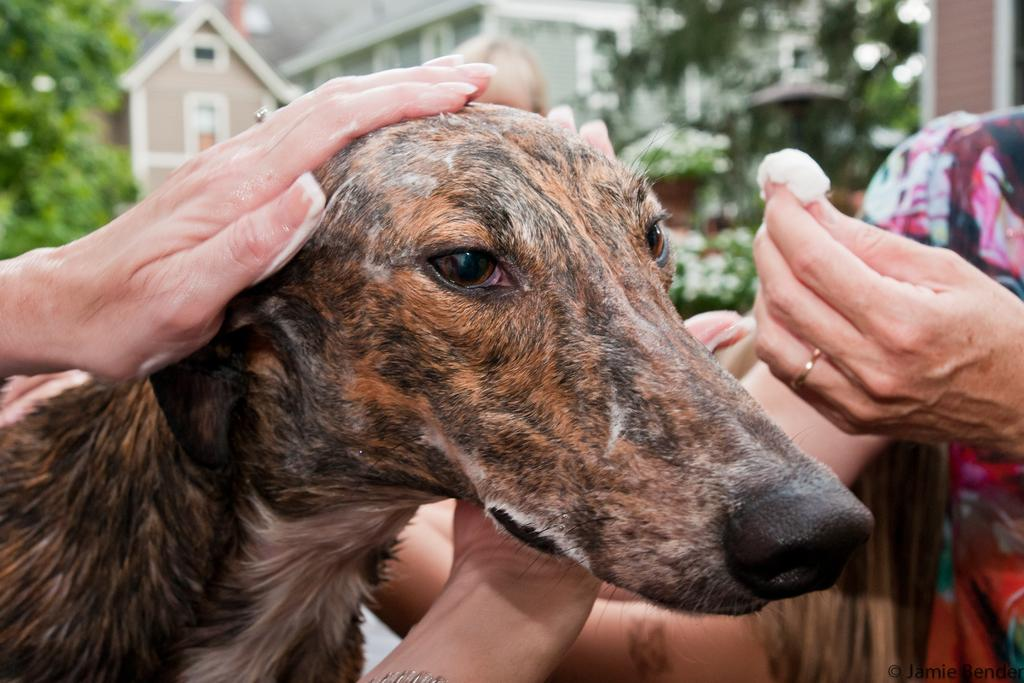What animal is located on the left side of the image? There is a dog on the left side of the image. What other subject is present on the right side of the image? There is a person on the right side of the image. What can be seen in the background of the image? There are buildings and trees in the background of the image. What type of salt is being used by the dog in the image? There is no salt present in the image, as it features a dog and a person with no indication of salt being used. 